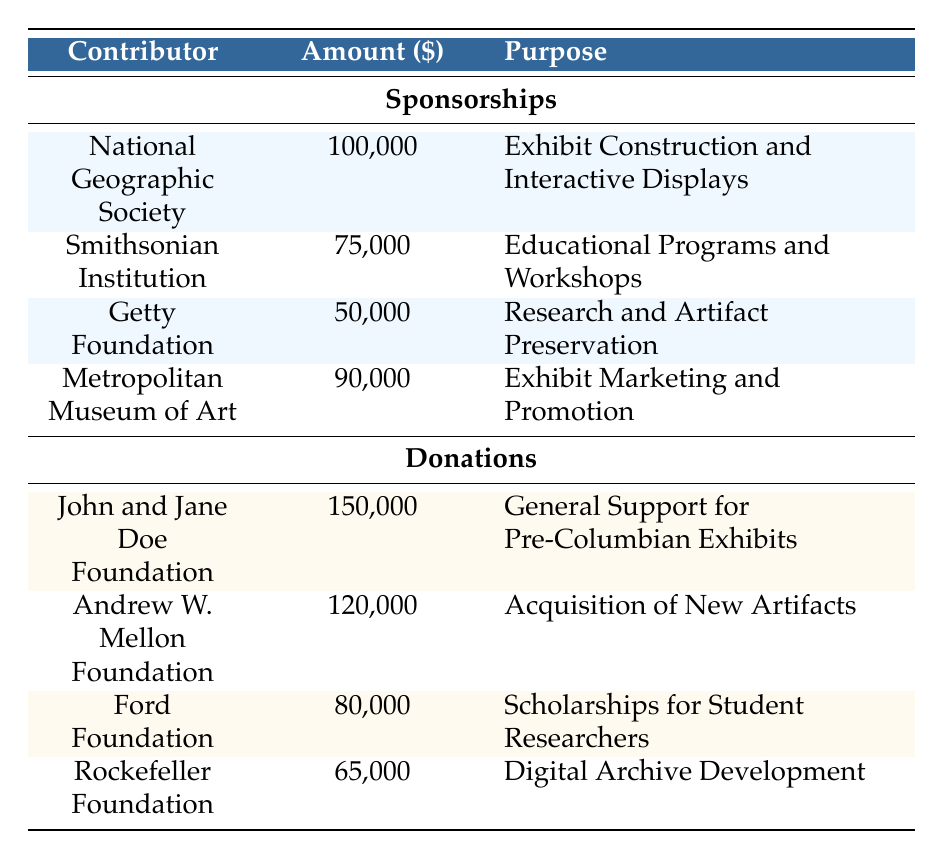What is the total amount of sponsorship contributions reported in the table? To find the total amount of sponsorship contributions, I need to sum the amounts from each contributor listed in the Sponsorship section: 100,000 + 75,000 + 50,000 + 90,000 = 315,000.
Answer: 315,000 Which organization contributed the most to the Pre-Columbian exhibits? By examining the Sponsorship section, the highest amount is contributed by the National Geographic Society with 100,000.
Answer: National Geographic Society Is the amount donated by the John and Jane Doe Foundation more than the combined contributions of the Getty Foundation and Rockefeller Foundation? First, I add the contributions of the Getty Foundation (50,000) and the Rockefeller Foundation (65,000), which equals 115,000. The John and Jane Doe Foundation donated 150,000, which is greater than 115,000.
Answer: Yes What is the total amount donated by the foundations listed in the Donations section? I will sum the amounts from each donor in the Donations section: 150,000 + 120,000 + 80,000 + 65,000 = 415,000.
Answer: 415,000 Is the total sponsorship amount equal to the total donations? The total sponsorship amount is 315,000, while the total donations amount is 415,000. Since 315,000 is not equal to 415,000, they are different.
Answer: No What percentage of the total contributions is represented by the contribution of the Metropolitan Museum of Art? First, I sum the total contributions: 315,000 (sponsorships) + 415,000 (donations) = 730,000. Next, I determine the percentage contributed by the Metropolitan Museum of Art, which donated 90,000. The calculation is (90,000 / 730,000) * 100 = 12.33%.
Answer: 12.33% Which purpose has the highest single sponsorship amount associated with it? Looking at the Sponsorship section, the highest single sponsorship amount is 100,000 for the purpose of Exhibit Construction and Interactive Displays from the National Geographic Society.
Answer: Exhibit Construction and Interactive Displays From which foundation was the contribution for the Acquisition of New Artifacts received? The table shows that the contribution for the Acquisition of New Artifacts was received from the Andrew W. Mellon Foundation, which donated 120,000.
Answer: Andrew W. Mellon Foundation 